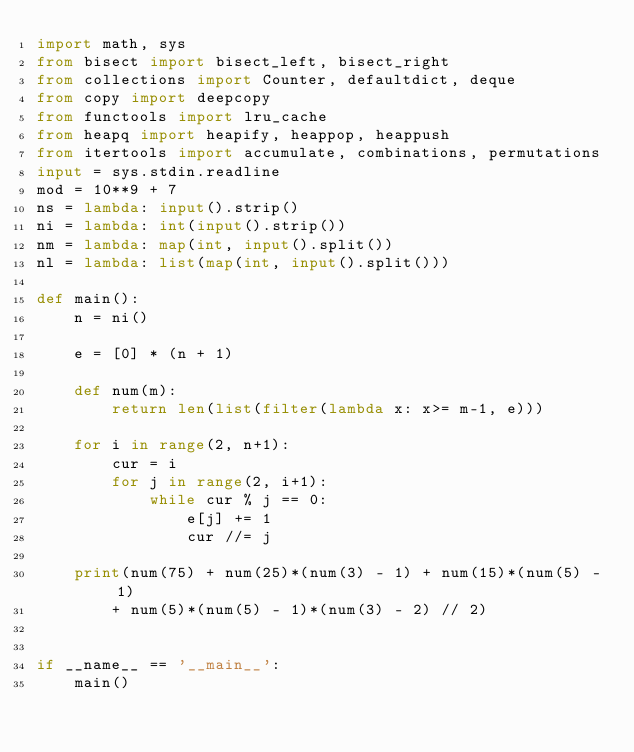<code> <loc_0><loc_0><loc_500><loc_500><_Python_>import math, sys
from bisect import bisect_left, bisect_right
from collections import Counter, defaultdict, deque
from copy import deepcopy
from functools import lru_cache
from heapq import heapify, heappop, heappush
from itertools import accumulate, combinations, permutations
input = sys.stdin.readline
mod = 10**9 + 7
ns = lambda: input().strip()
ni = lambda: int(input().strip())
nm = lambda: map(int, input().split())
nl = lambda: list(map(int, input().split()))

def main():
    n = ni()

    e = [0] * (n + 1)

    def num(m):
        return len(list(filter(lambda x: x>= m-1, e)))

    for i in range(2, n+1):
        cur = i
        for j in range(2, i+1):
            while cur % j == 0:
                e[j] += 1
                cur //= j
    
    print(num(75) + num(25)*(num(3) - 1) + num(15)*(num(5) - 1)
        + num(5)*(num(5) - 1)*(num(3) - 2) // 2)


if __name__ == '__main__':
    main()</code> 